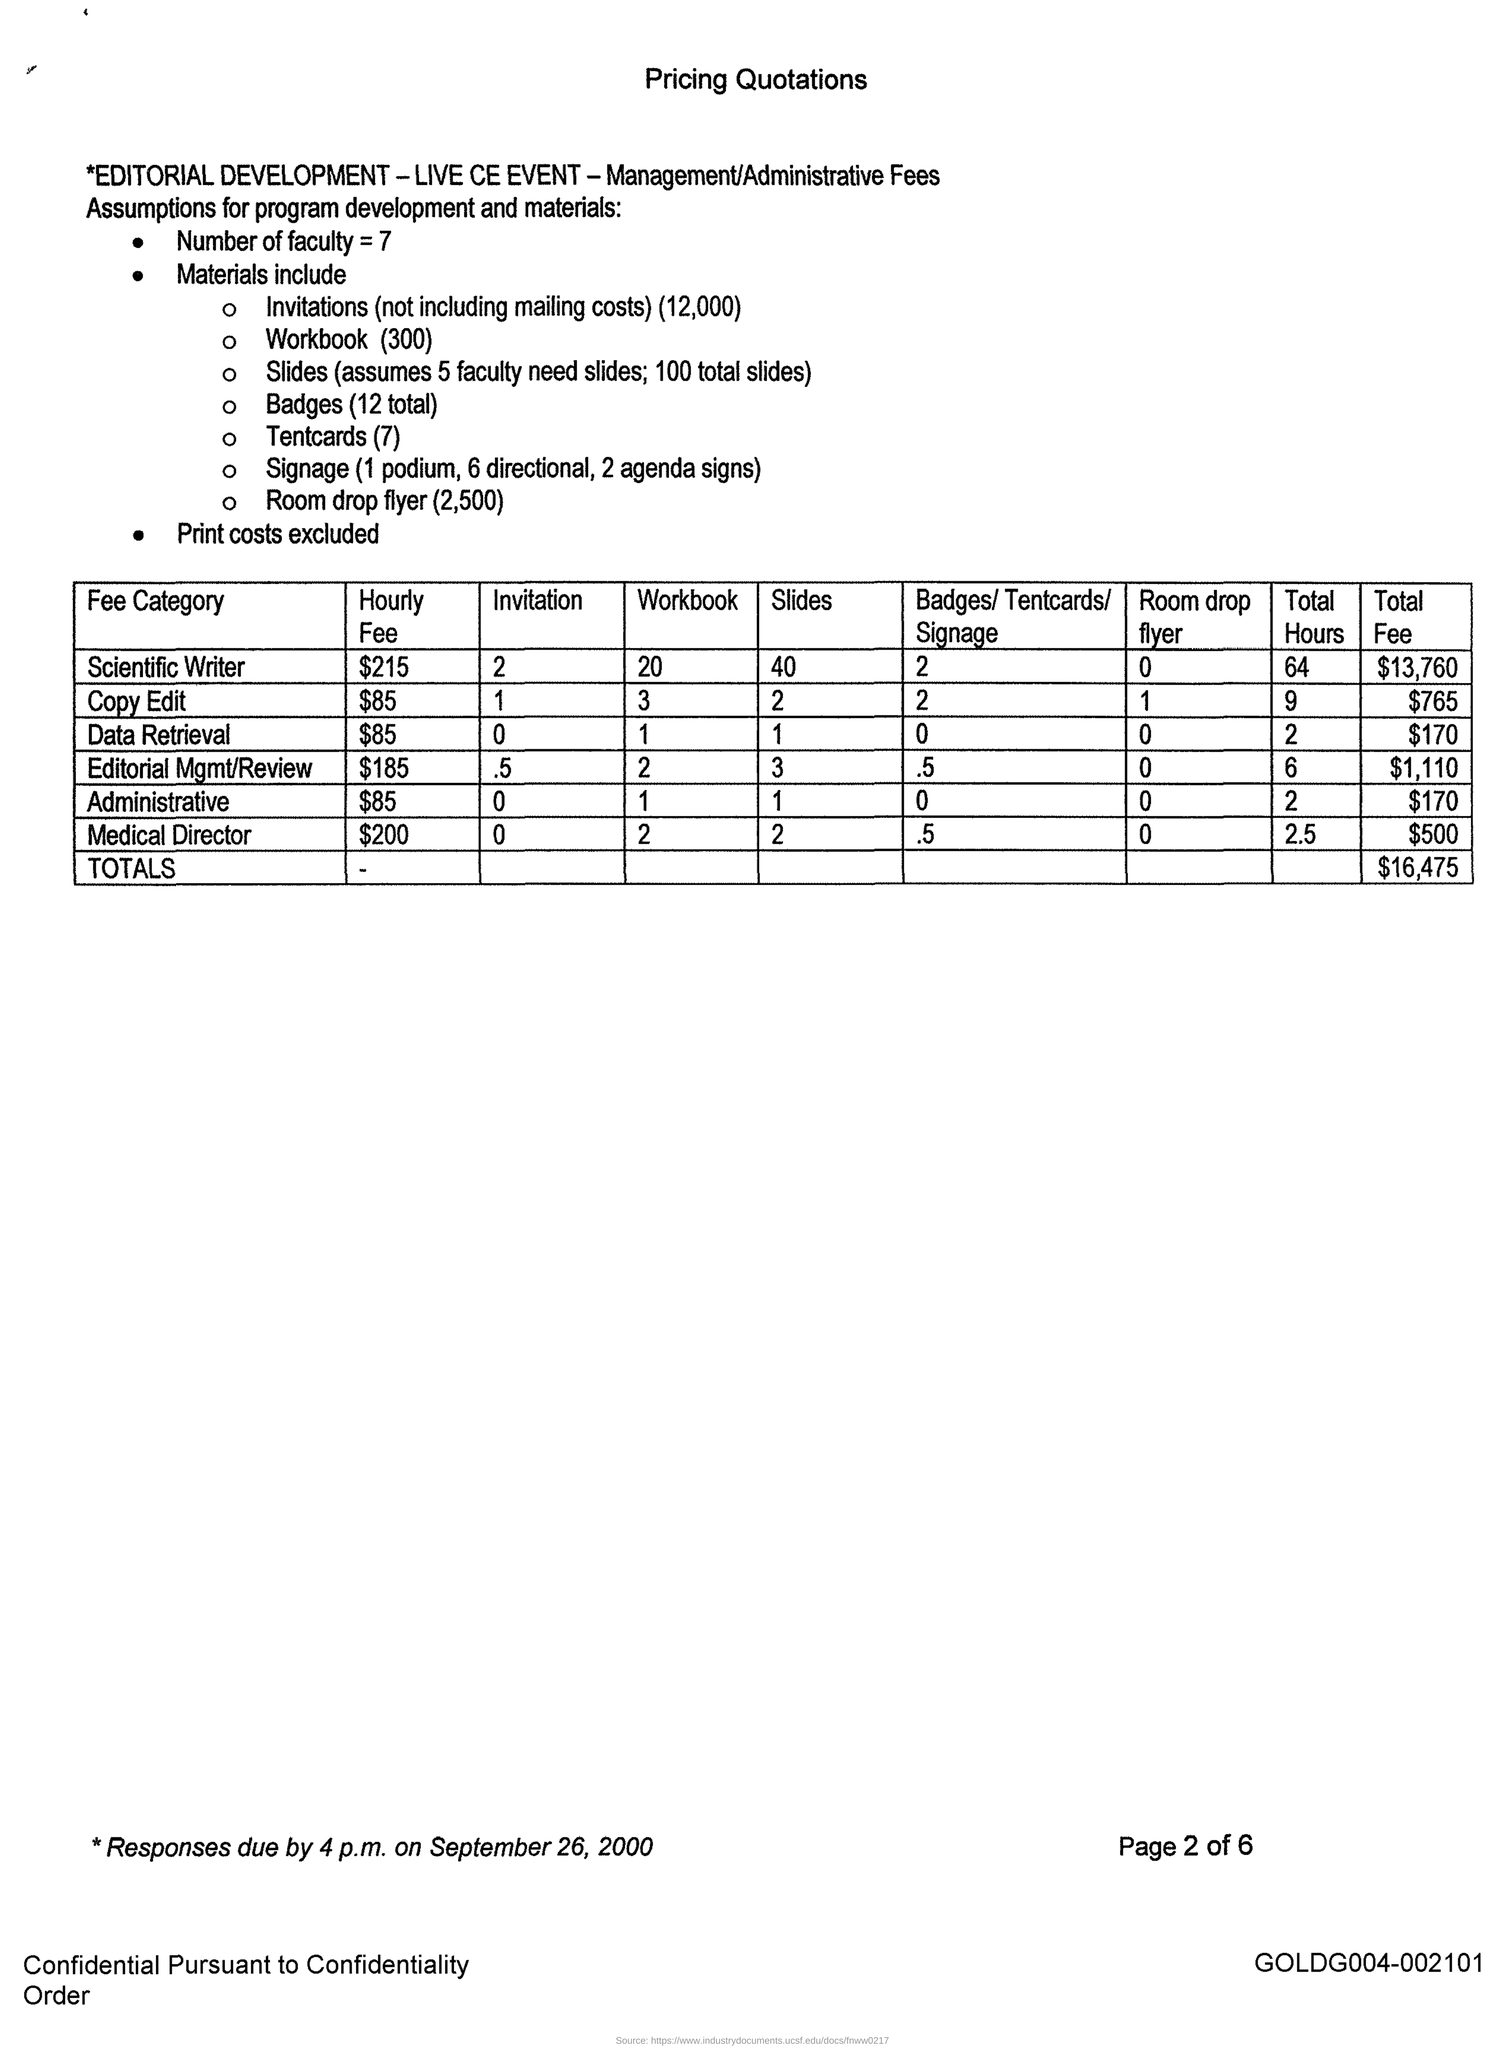What is the hourly fee for scientific writer ?
Your answer should be compact. $215. How many number of faculty are there ?
Keep it short and to the point. 7. What is the total cost of the pricing quotation ?
Provide a short and direct response. $16,475. How many slides are used for scientific Writer ?
Your answer should be very brief. 40. 